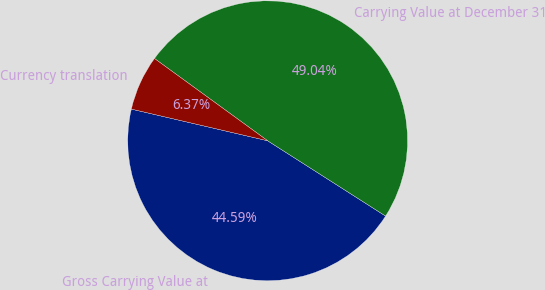Convert chart to OTSL. <chart><loc_0><loc_0><loc_500><loc_500><pie_chart><fcel>Gross Carrying Value at<fcel>Carrying Value at December 31<fcel>Currency translation<nl><fcel>44.59%<fcel>49.04%<fcel>6.37%<nl></chart> 